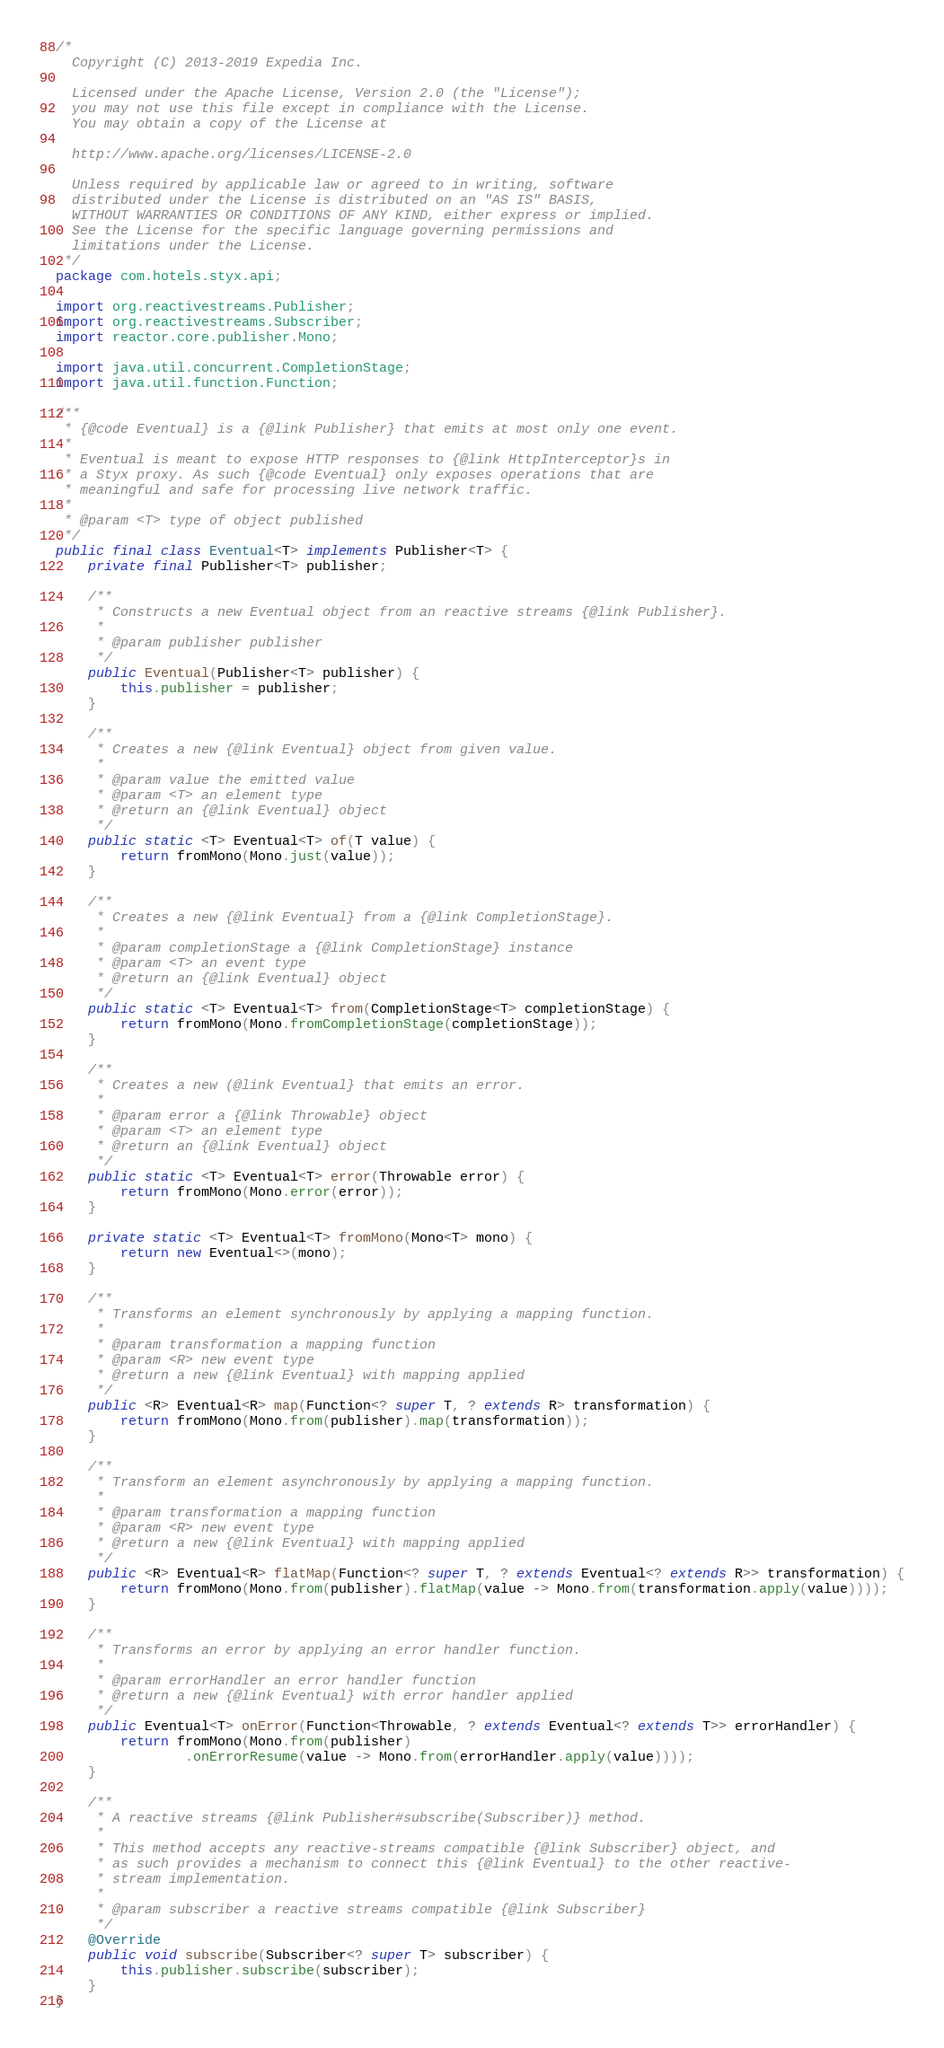Convert code to text. <code><loc_0><loc_0><loc_500><loc_500><_Java_>/*
  Copyright (C) 2013-2019 Expedia Inc.

  Licensed under the Apache License, Version 2.0 (the "License");
  you may not use this file except in compliance with the License.
  You may obtain a copy of the License at

  http://www.apache.org/licenses/LICENSE-2.0

  Unless required by applicable law or agreed to in writing, software
  distributed under the License is distributed on an "AS IS" BASIS,
  WITHOUT WARRANTIES OR CONDITIONS OF ANY KIND, either express or implied.
  See the License for the specific language governing permissions and
  limitations under the License.
 */
package com.hotels.styx.api;

import org.reactivestreams.Publisher;
import org.reactivestreams.Subscriber;
import reactor.core.publisher.Mono;

import java.util.concurrent.CompletionStage;
import java.util.function.Function;

/**
 * {@code Eventual} is a {@link Publisher} that emits at most only one event.
 *
 * Eventual is meant to expose HTTP responses to {@link HttpInterceptor}s in
 * a Styx proxy. As such {@code Eventual} only exposes operations that are
 * meaningful and safe for processing live network traffic.
 *
 * @param <T> type of object published
 */
public final class Eventual<T> implements Publisher<T> {
    private final Publisher<T> publisher;

    /**
     * Constructs a new Eventual object from an reactive streams {@link Publisher}.
     *
     * @param publisher publisher
     */
    public Eventual(Publisher<T> publisher) {
        this.publisher = publisher;
    }

    /**
     * Creates a new {@link Eventual} object from given value.
     *
     * @param value the emitted value
     * @param <T> an element type
     * @return an {@link Eventual} object
     */
    public static <T> Eventual<T> of(T value) {
        return fromMono(Mono.just(value));
    }

    /**
     * Creates a new {@link Eventual} from a {@link CompletionStage}.
     *
     * @param completionStage a {@link CompletionStage} instance
     * @param <T> an event type
     * @return an {@link Eventual} object
     */
    public static <T> Eventual<T> from(CompletionStage<T> completionStage) {
        return fromMono(Mono.fromCompletionStage(completionStage));
    }

    /**
     * Creates a new (@link Eventual} that emits an error.
     *
     * @param error a {@link Throwable} object
     * @param <T> an element type
     * @return an {@link Eventual} object
     */
    public static <T> Eventual<T> error(Throwable error) {
        return fromMono(Mono.error(error));
    }

    private static <T> Eventual<T> fromMono(Mono<T> mono) {
        return new Eventual<>(mono);
    }

    /**
     * Transforms an element synchronously by applying a mapping function.
     *
     * @param transformation a mapping function
     * @param <R> new event type
     * @return a new {@link Eventual} with mapping applied
     */
    public <R> Eventual<R> map(Function<? super T, ? extends R> transformation) {
        return fromMono(Mono.from(publisher).map(transformation));
    }

    /**
     * Transform an element asynchronously by applying a mapping function.
     *
     * @param transformation a mapping function
     * @param <R> new event type
     * @return a new {@link Eventual} with mapping applied
     */
    public <R> Eventual<R> flatMap(Function<? super T, ? extends Eventual<? extends R>> transformation) {
        return fromMono(Mono.from(publisher).flatMap(value -> Mono.from(transformation.apply(value))));
    }

    /**
     * Transforms an error by applying an error handler function.
     *
     * @param errorHandler an error handler function
     * @return a new {@link Eventual} with error handler applied
     */
    public Eventual<T> onError(Function<Throwable, ? extends Eventual<? extends T>> errorHandler) {
        return fromMono(Mono.from(publisher)
                .onErrorResume(value -> Mono.from(errorHandler.apply(value))));
    }

    /**
     * A reactive streams {@link Publisher#subscribe(Subscriber)} method.
     *
     * This method accepts any reactive-streams compatible {@link Subscriber} object, and
     * as such provides a mechanism to connect this {@link Eventual} to the other reactive-
     * stream implementation.
     *
     * @param subscriber a reactive streams compatible {@link Subscriber}
     */
    @Override
    public void subscribe(Subscriber<? super T> subscriber) {
        this.publisher.subscribe(subscriber);
    }
}

</code> 